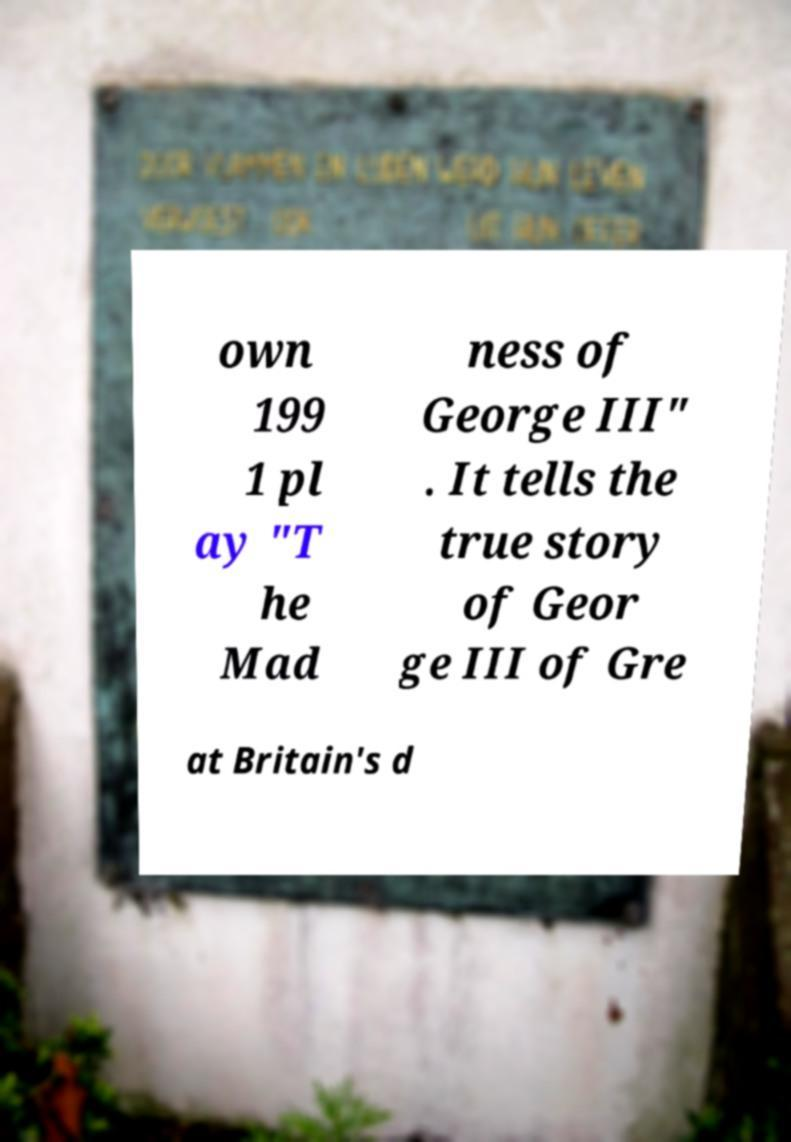Please identify and transcribe the text found in this image. own 199 1 pl ay "T he Mad ness of George III" . It tells the true story of Geor ge III of Gre at Britain's d 